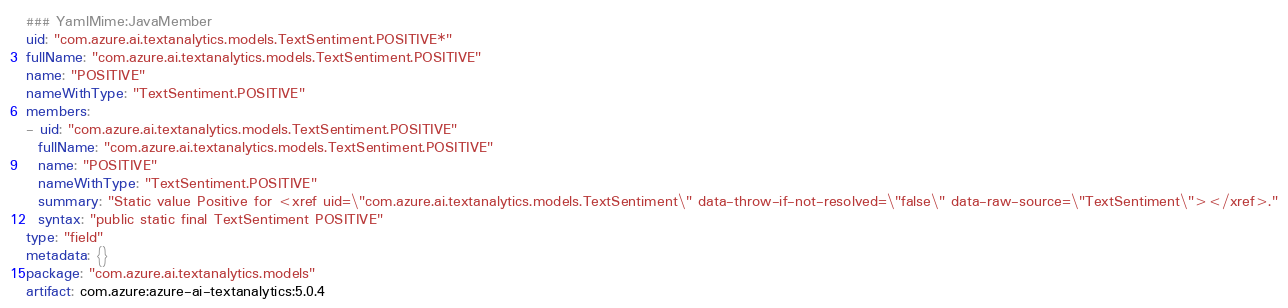<code> <loc_0><loc_0><loc_500><loc_500><_YAML_>### YamlMime:JavaMember
uid: "com.azure.ai.textanalytics.models.TextSentiment.POSITIVE*"
fullName: "com.azure.ai.textanalytics.models.TextSentiment.POSITIVE"
name: "POSITIVE"
nameWithType: "TextSentiment.POSITIVE"
members:
- uid: "com.azure.ai.textanalytics.models.TextSentiment.POSITIVE"
  fullName: "com.azure.ai.textanalytics.models.TextSentiment.POSITIVE"
  name: "POSITIVE"
  nameWithType: "TextSentiment.POSITIVE"
  summary: "Static value Positive for <xref uid=\"com.azure.ai.textanalytics.models.TextSentiment\" data-throw-if-not-resolved=\"false\" data-raw-source=\"TextSentiment\"></xref>."
  syntax: "public static final TextSentiment POSITIVE"
type: "field"
metadata: {}
package: "com.azure.ai.textanalytics.models"
artifact: com.azure:azure-ai-textanalytics:5.0.4
</code> 